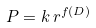<formula> <loc_0><loc_0><loc_500><loc_500>P = k \, r ^ { f ( D ) }</formula> 